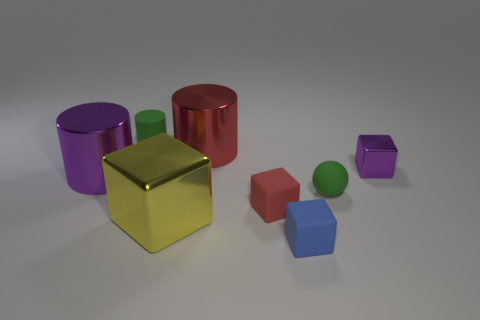Can you tell me the number of objects on the surface and their colors? There are seven objects on the surface. Starting from the left, there's a purple cylinder, a golden cube, a green cuboid, a red cylinder, a red cube, a green sphere, and finally, a small purple cube. 